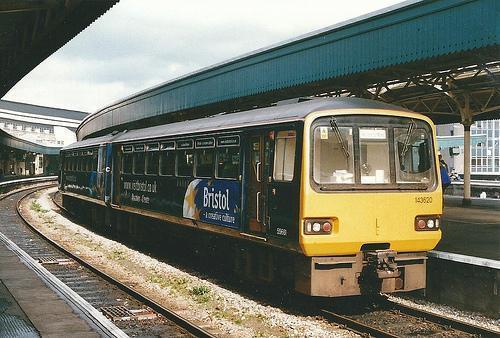How many people are pictured?
Give a very brief answer. 1. 